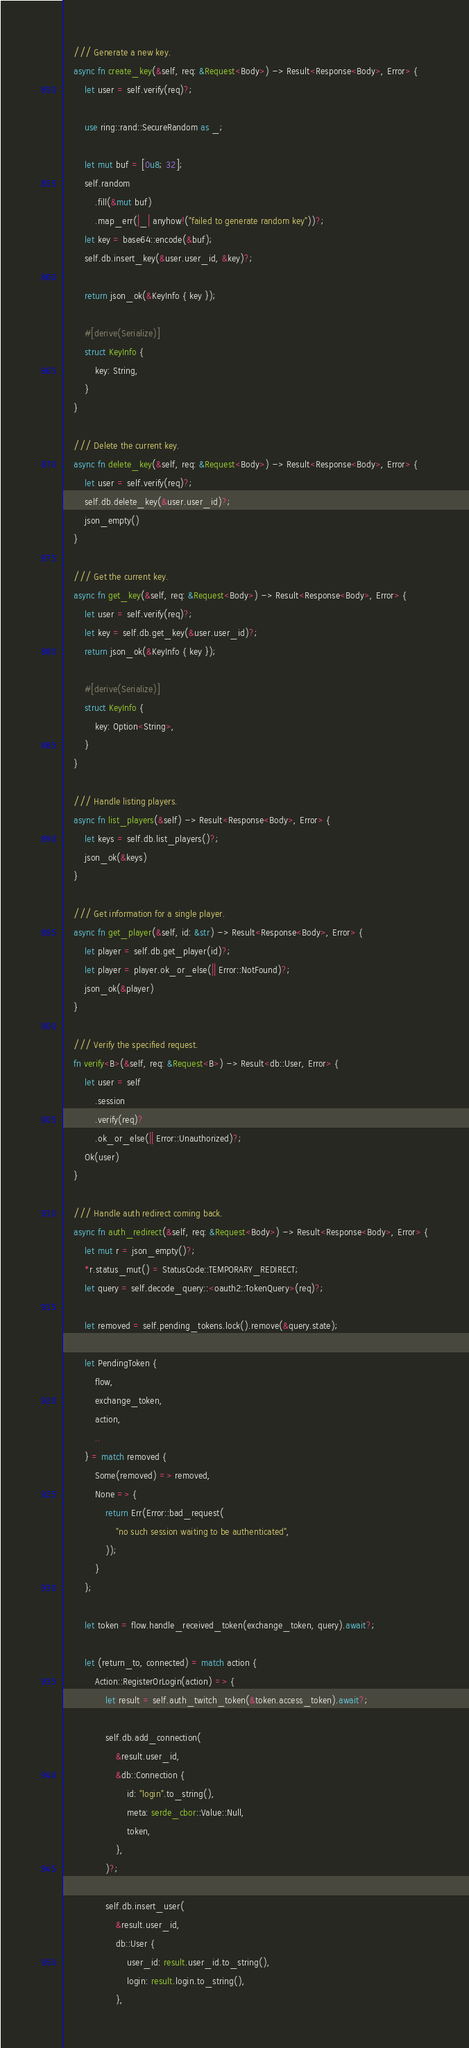Convert code to text. <code><loc_0><loc_0><loc_500><loc_500><_Rust_>    /// Generate a new key.
    async fn create_key(&self, req: &Request<Body>) -> Result<Response<Body>, Error> {
        let user = self.verify(req)?;

        use ring::rand::SecureRandom as _;

        let mut buf = [0u8; 32];
        self.random
            .fill(&mut buf)
            .map_err(|_| anyhow!("failed to generate random key"))?;
        let key = base64::encode(&buf);
        self.db.insert_key(&user.user_id, &key)?;

        return json_ok(&KeyInfo { key });

        #[derive(Serialize)]
        struct KeyInfo {
            key: String,
        }
    }

    /// Delete the current key.
    async fn delete_key(&self, req: &Request<Body>) -> Result<Response<Body>, Error> {
        let user = self.verify(req)?;
        self.db.delete_key(&user.user_id)?;
        json_empty()
    }

    /// Get the current key.
    async fn get_key(&self, req: &Request<Body>) -> Result<Response<Body>, Error> {
        let user = self.verify(req)?;
        let key = self.db.get_key(&user.user_id)?;
        return json_ok(&KeyInfo { key });

        #[derive(Serialize)]
        struct KeyInfo {
            key: Option<String>,
        }
    }

    /// Handle listing players.
    async fn list_players(&self) -> Result<Response<Body>, Error> {
        let keys = self.db.list_players()?;
        json_ok(&keys)
    }

    /// Get information for a single player.
    async fn get_player(&self, id: &str) -> Result<Response<Body>, Error> {
        let player = self.db.get_player(id)?;
        let player = player.ok_or_else(|| Error::NotFound)?;
        json_ok(&player)
    }

    /// Verify the specified request.
    fn verify<B>(&self, req: &Request<B>) -> Result<db::User, Error> {
        let user = self
            .session
            .verify(req)?
            .ok_or_else(|| Error::Unauthorized)?;
        Ok(user)
    }

    /// Handle auth redirect coming back.
    async fn auth_redirect(&self, req: &Request<Body>) -> Result<Response<Body>, Error> {
        let mut r = json_empty()?;
        *r.status_mut() = StatusCode::TEMPORARY_REDIRECT;
        let query = self.decode_query::<oauth2::TokenQuery>(req)?;

        let removed = self.pending_tokens.lock().remove(&query.state);

        let PendingToken {
            flow,
            exchange_token,
            action,
            ..
        } = match removed {
            Some(removed) => removed,
            None => {
                return Err(Error::bad_request(
                    "no such session waiting to be authenticated",
                ));
            }
        };

        let token = flow.handle_received_token(exchange_token, query).await?;

        let (return_to, connected) = match action {
            Action::RegisterOrLogin(action) => {
                let result = self.auth_twitch_token(&token.access_token).await?;

                self.db.add_connection(
                    &result.user_id,
                    &db::Connection {
                        id: "login".to_string(),
                        meta: serde_cbor::Value::Null,
                        token,
                    },
                )?;

                self.db.insert_user(
                    &result.user_id,
                    db::User {
                        user_id: result.user_id.to_string(),
                        login: result.login.to_string(),
                    },</code> 